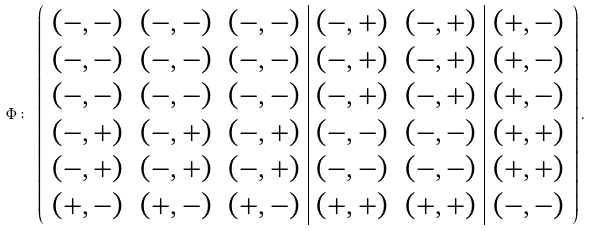<formula> <loc_0><loc_0><loc_500><loc_500>\Phi \colon \, \left ( \begin{array} { c c c | c c | c } ( - , - ) & ( - , - ) & ( - , - ) & ( - , + ) & ( - , + ) & ( + , - ) \\ ( - , - ) & ( - , - ) & ( - , - ) & ( - , + ) & ( - , + ) & ( + , - ) \\ ( - , - ) & ( - , - ) & ( - , - ) & ( - , + ) & ( - , + ) & ( + , - ) \\ ( - , + ) & ( - , + ) & ( - , + ) & ( - , - ) & ( - , - ) & ( + , + ) \\ ( - , + ) & ( - , + ) & ( - , + ) & ( - , - ) & ( - , - ) & ( + , + ) \\ ( + , - ) & ( + , - ) & ( + , - ) & ( + , + ) & ( + , + ) & ( - , - ) \end{array} \right ) .</formula> 